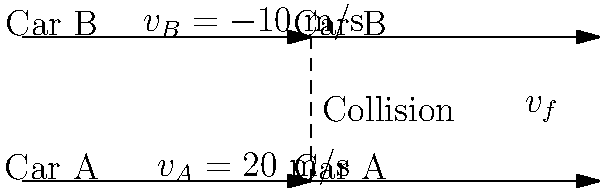Two diplomatic vehicles, Car A (mass 2000 kg) and Car B (mass 1500 kg), collide on a straight road. Before the collision, Car A is traveling east at 20 m/s, while Car B is traveling west at 10 m/s. After the collision, the cars stick together and move as one unit. Calculate the final velocity of the combined cars after the collision. To solve this problem, we'll use the principle of conservation of momentum:

1. Define the variables:
   $m_A = 2000$ kg, $m_B = 1500$ kg
   $v_A = 20$ m/s (east, positive), $v_B = -10$ m/s (west, negative)
   $v_f$ = final velocity (unknown)

2. Apply the conservation of momentum equation:
   $$(m_A \cdot v_A) + (m_B \cdot v_B) = (m_A + m_B) \cdot v_f$$

3. Substitute the known values:
   $$(2000 \cdot 20) + (1500 \cdot (-10)) = (2000 + 1500) \cdot v_f$$

4. Simplify the left side of the equation:
   $$40,000 - 15,000 = 3500 \cdot v_f$$
   $$25,000 = 3500 \cdot v_f$$

5. Solve for $v_f$:
   $$v_f = \frac{25,000}{3500} \approx 7.14 \text{ m/s}$$

The final velocity of the combined cars after the collision is approximately 7.14 m/s in the eastward direction.
Answer: 7.14 m/s east 